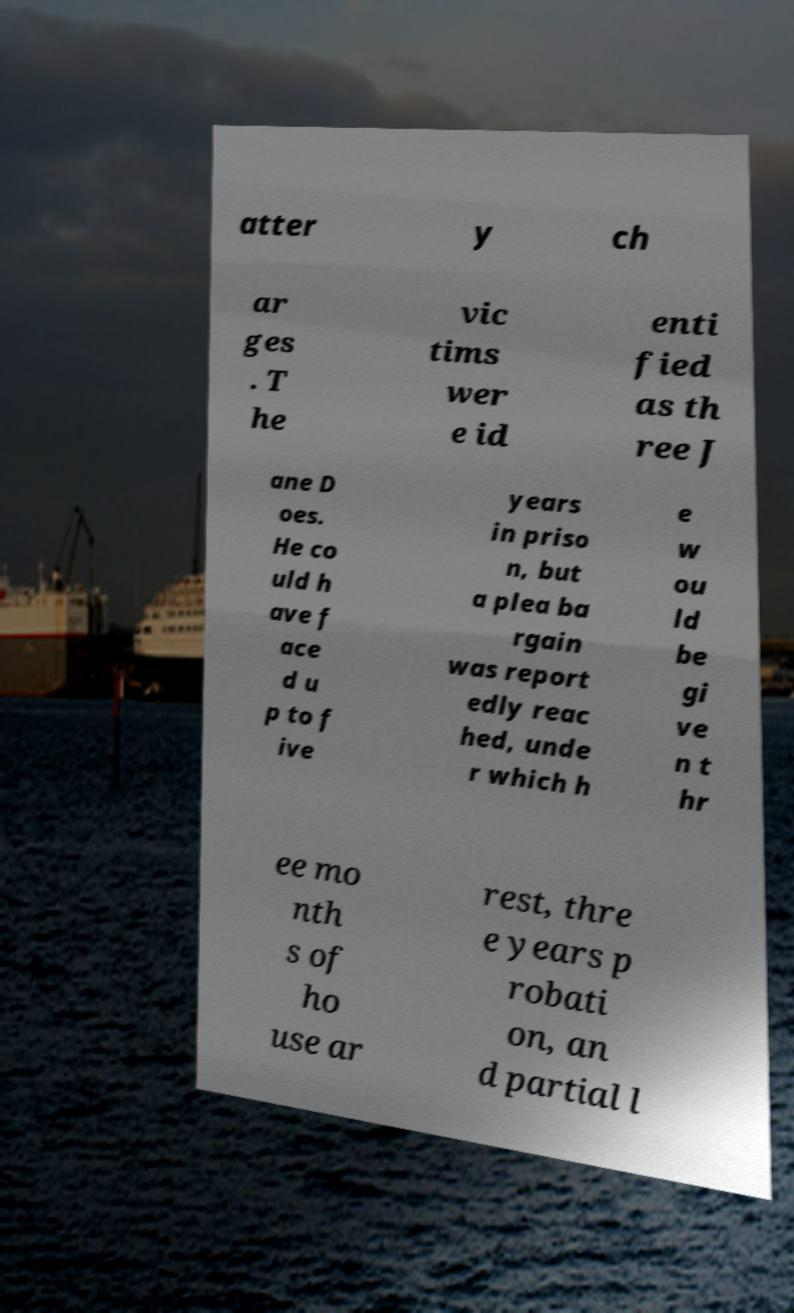There's text embedded in this image that I need extracted. Can you transcribe it verbatim? atter y ch ar ges . T he vic tims wer e id enti fied as th ree J ane D oes. He co uld h ave f ace d u p to f ive years in priso n, but a plea ba rgain was report edly reac hed, unde r which h e w ou ld be gi ve n t hr ee mo nth s of ho use ar rest, thre e years p robati on, an d partial l 